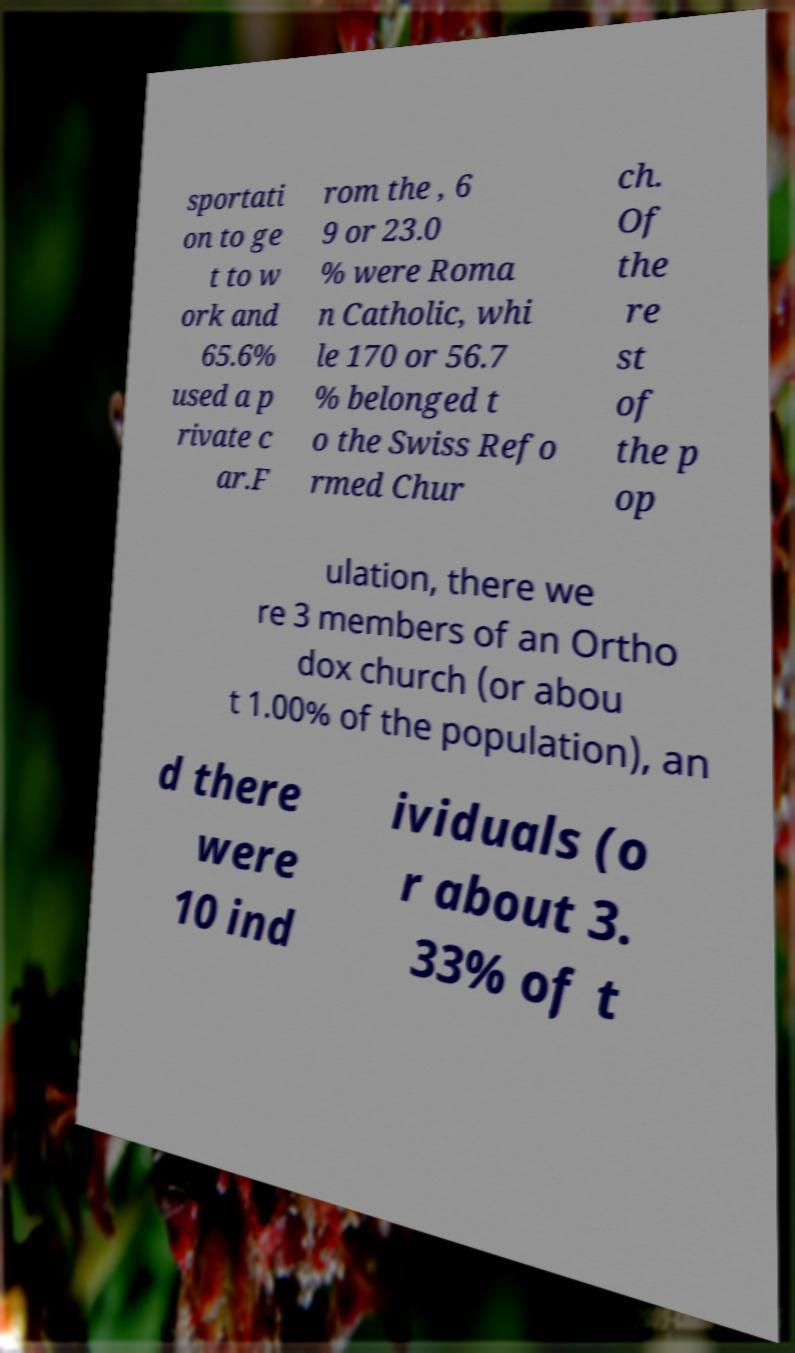Can you read and provide the text displayed in the image?This photo seems to have some interesting text. Can you extract and type it out for me? sportati on to ge t to w ork and 65.6% used a p rivate c ar.F rom the , 6 9 or 23.0 % were Roma n Catholic, whi le 170 or 56.7 % belonged t o the Swiss Refo rmed Chur ch. Of the re st of the p op ulation, there we re 3 members of an Ortho dox church (or abou t 1.00% of the population), an d there were 10 ind ividuals (o r about 3. 33% of t 